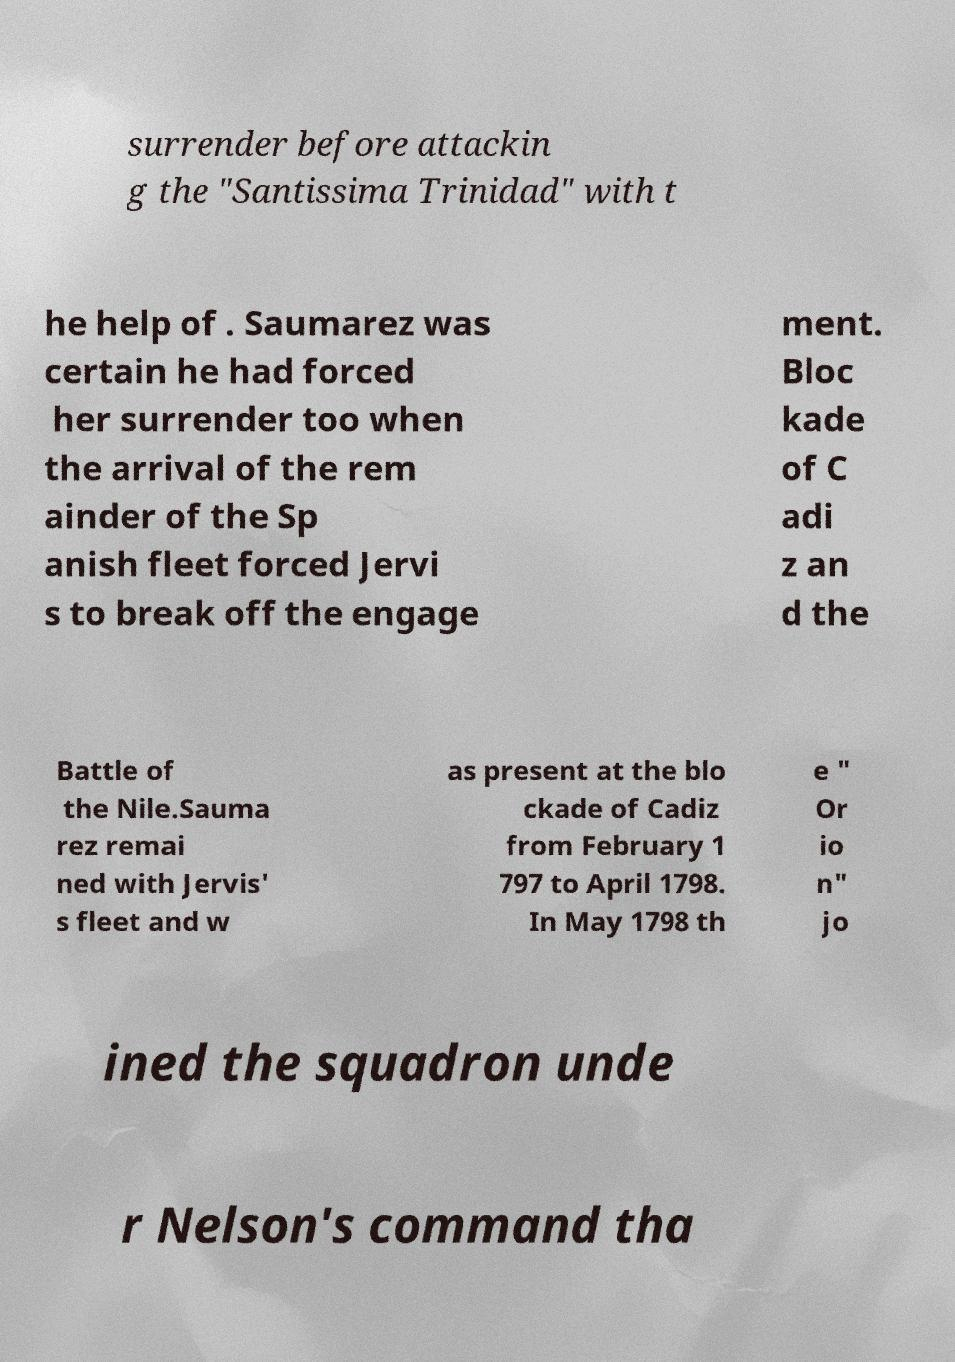For documentation purposes, I need the text within this image transcribed. Could you provide that? surrender before attackin g the "Santissima Trinidad" with t he help of . Saumarez was certain he had forced her surrender too when the arrival of the rem ainder of the Sp anish fleet forced Jervi s to break off the engage ment. Bloc kade of C adi z an d the Battle of the Nile.Sauma rez remai ned with Jervis' s fleet and w as present at the blo ckade of Cadiz from February 1 797 to April 1798. In May 1798 th e " Or io n" jo ined the squadron unde r Nelson's command tha 